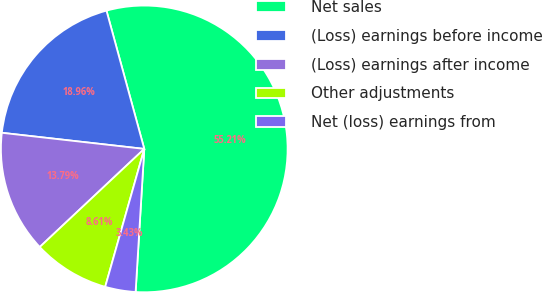Convert chart to OTSL. <chart><loc_0><loc_0><loc_500><loc_500><pie_chart><fcel>Net sales<fcel>(Loss) earnings before income<fcel>(Loss) earnings after income<fcel>Other adjustments<fcel>Net (loss) earnings from<nl><fcel>55.21%<fcel>18.96%<fcel>13.79%<fcel>8.61%<fcel>3.43%<nl></chart> 